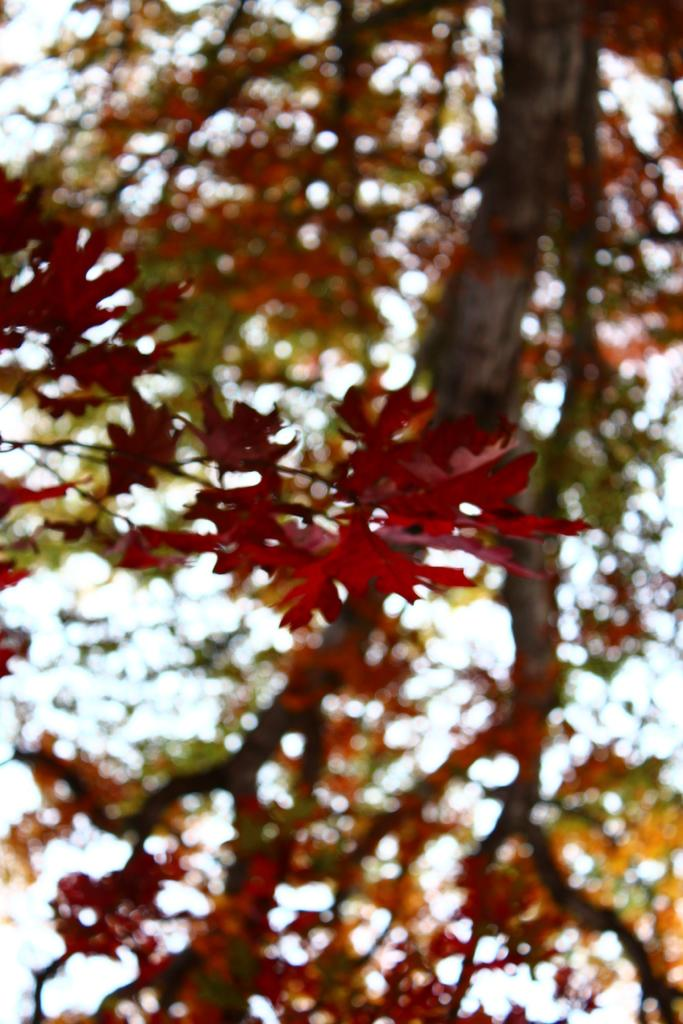What is located in the foreground of the image? There is a tree in the foreground of the image. What can be seen in the background of the image? The sky is visible in the background of the image. What type of hen is participating in the discussion in the image? There is no hen or discussion present in the image; it features a tree and the sky. 